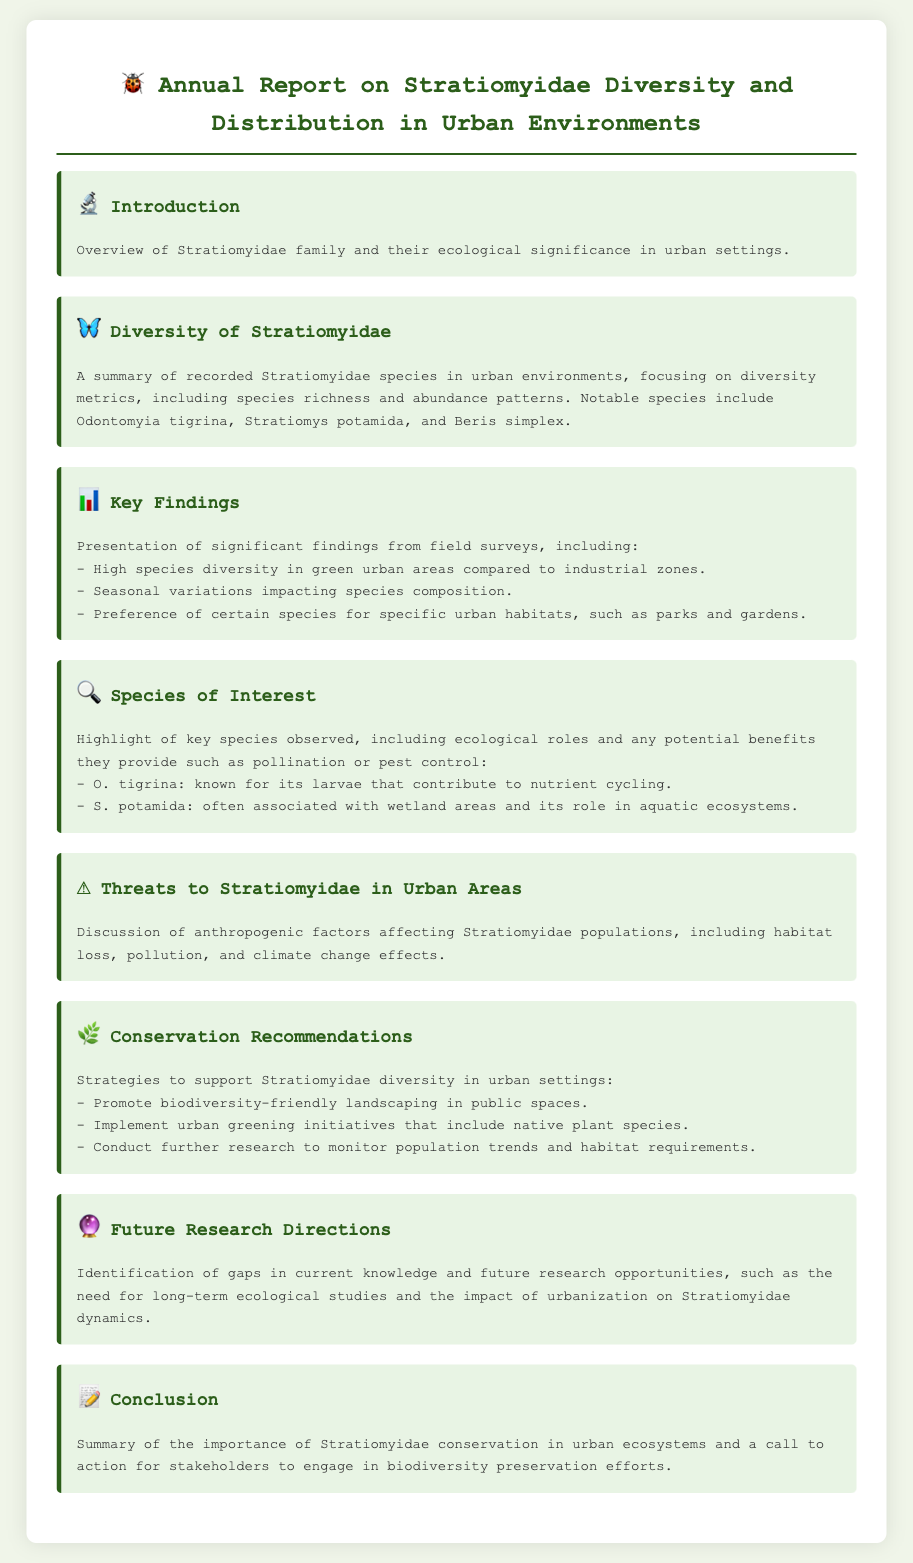What is the title of the report? The title of the report is specified in the document header.
Answer: Annual Report on Stratiomyidae Diversity and Distribution in Urban Environments Which species is noted for its contribution to nutrient cycling? The species is mentioned in the section highlighting key species and their ecological roles.
Answer: O. tigrina What are the two urban habitats mentioned for certain Stratiomyidae species? The habitats are discussed in the key findings and species of interest sections.
Answer: Parks and gardens What significant finding relates to urban area types? This finding is presented in the key findings section regarding species diversity.
Answer: High species diversity in green urban areas compared to industrial zones What is recommended to support Stratiomyidae diversity? The recommendations are outlined in the conservation recommendations section.
Answer: Promote biodiversity-friendly landscaping in public spaces How many species of interest are highlighted in the document? The document specifically mentions two species of interest in the relevant section.
Answer: Two What is a potential effect of climate change mentioned? The effect is discussed in the threats to Stratiomyidae section.
Answer: Pollution What is one future research direction identified? The future research direction is summarized in the document's future research directions section.
Answer: Long-term ecological studies 